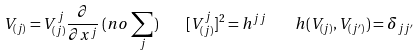<formula> <loc_0><loc_0><loc_500><loc_500>V _ { ( j ) } = V _ { ( j ) } ^ { j } \frac { \partial } { \partial x ^ { j } } \, ( n o \, \sum _ { j } ) \quad [ V _ { ( j ) } ^ { j } ] ^ { 2 } = h ^ { j j } \quad h ( V _ { ( j ) } , V _ { ( j ^ { \prime } ) } ) = \delta _ { j j ^ { \prime } }</formula> 